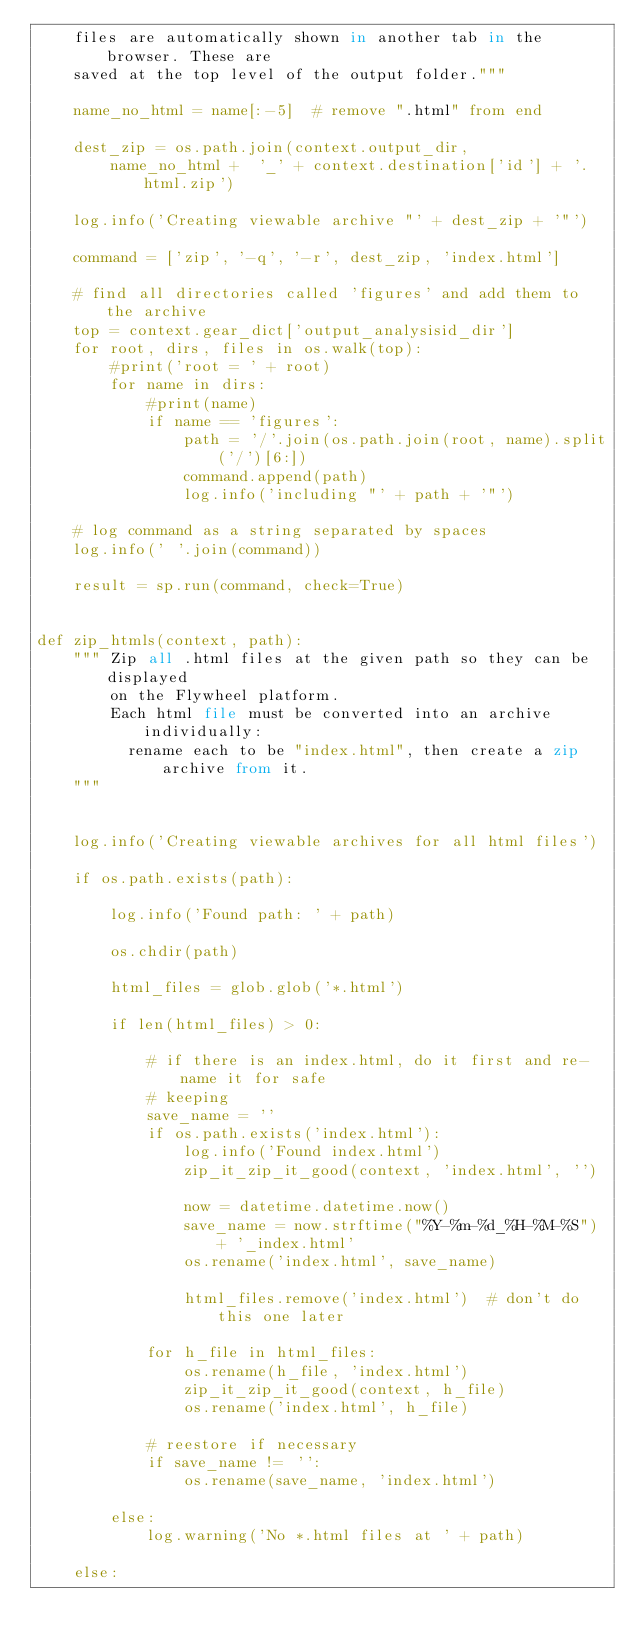<code> <loc_0><loc_0><loc_500><loc_500><_Python_>    files are automatically shown in another tab in the browser. These are
    saved at the top level of the output folder."""

    name_no_html = name[:-5]  # remove ".html" from end

    dest_zip = os.path.join(context.output_dir,
        name_no_html +  '_' + context.destination['id'] + '.html.zip')

    log.info('Creating viewable archive "' + dest_zip + '"')

    command = ['zip', '-q', '-r', dest_zip, 'index.html']

    # find all directories called 'figures' and add them to the archive
    top = context.gear_dict['output_analysisid_dir']
    for root, dirs, files in os.walk(top):
        #print('root = ' + root)
        for name in dirs:
            #print(name)
            if name == 'figures':
                path = '/'.join(os.path.join(root, name).split('/')[6:])
                command.append(path)
                log.info('including "' + path + '"')

    # log command as a string separated by spaces
    log.info(' '.join(command))

    result = sp.run(command, check=True)


def zip_htmls(context, path):
    """ Zip all .html files at the given path so they can be displayed
        on the Flywheel platform.
        Each html file must be converted into an archive individually:
          rename each to be "index.html", then create a zip archive from it.  
    """


    log.info('Creating viewable archives for all html files')

    if os.path.exists(path):

        log.info('Found path: ' + path)

        os.chdir(path)

        html_files = glob.glob('*.html')

        if len(html_files) > 0:

            # if there is an index.html, do it first and re-name it for safe 
            # keeping
            save_name = ''
            if os.path.exists('index.html'):
                log.info('Found index.html')
                zip_it_zip_it_good(context, 'index.html', '')

                now = datetime.datetime.now()
                save_name = now.strftime("%Y-%m-%d_%H-%M-%S") + '_index.html'
                os.rename('index.html', save_name)

                html_files.remove('index.html')  # don't do this one later

            for h_file in html_files:
                os.rename(h_file, 'index.html')
                zip_it_zip_it_good(context, h_file)
                os.rename('index.html', h_file)

            # reestore if necessary
            if save_name != '':
                os.rename(save_name, 'index.html')

        else:
            log.warning('No *.html files at ' + path)

    else:
</code> 